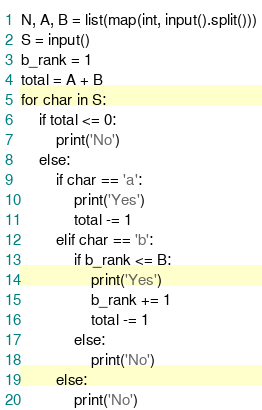Convert code to text. <code><loc_0><loc_0><loc_500><loc_500><_Python_>N, A, B = list(map(int, input().split()))
S = input()
b_rank = 1
total = A + B
for char in S:
    if total <= 0:
        print('No')
    else:
        if char == 'a':
            print('Yes')
            total -= 1
        elif char == 'b':
            if b_rank <= B:
                print('Yes')
                b_rank += 1
                total -= 1
            else:
                print('No')
        else:
            print('No')</code> 